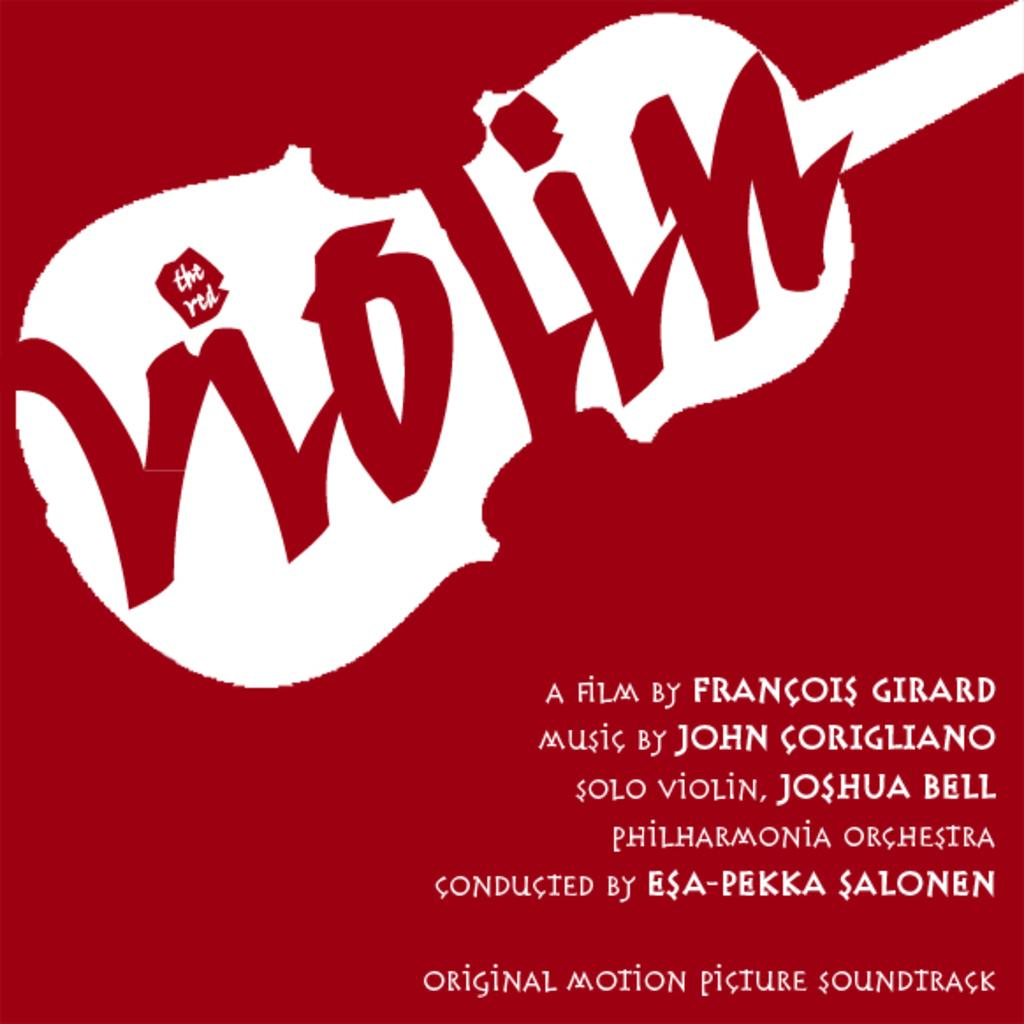<image>
Share a concise interpretation of the image provided. a film logo with the name Francois on it 